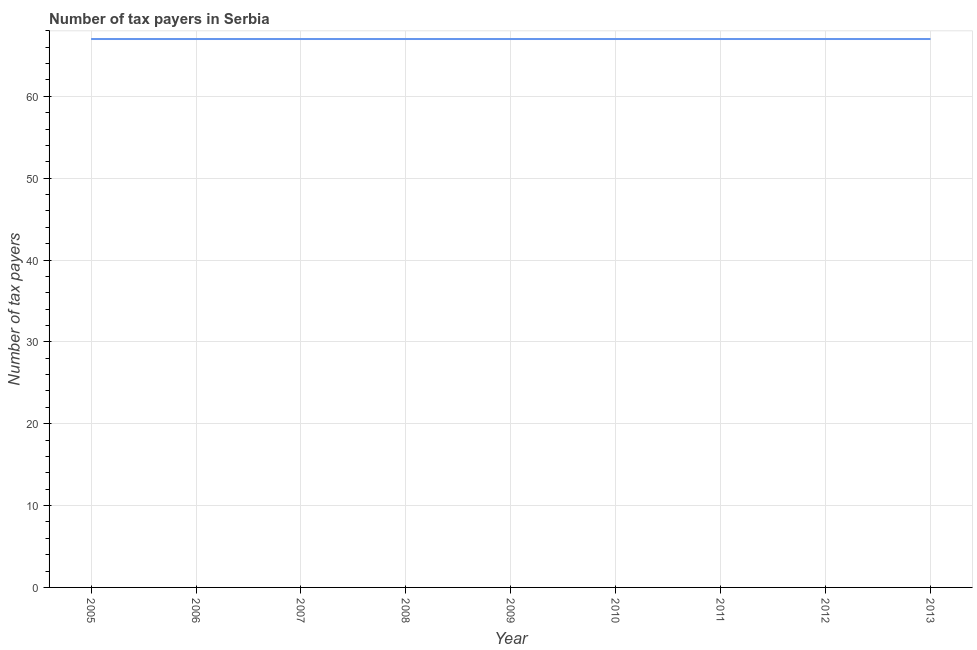What is the number of tax payers in 2011?
Your response must be concise. 67. Across all years, what is the maximum number of tax payers?
Your response must be concise. 67. Across all years, what is the minimum number of tax payers?
Give a very brief answer. 67. In which year was the number of tax payers maximum?
Keep it short and to the point. 2005. In which year was the number of tax payers minimum?
Provide a short and direct response. 2005. What is the sum of the number of tax payers?
Your answer should be very brief. 603. What is the average number of tax payers per year?
Keep it short and to the point. 67. What is the ratio of the number of tax payers in 2008 to that in 2011?
Give a very brief answer. 1. Is the difference between the number of tax payers in 2011 and 2012 greater than the difference between any two years?
Your response must be concise. Yes. What is the difference between the highest and the lowest number of tax payers?
Give a very brief answer. 0. In how many years, is the number of tax payers greater than the average number of tax payers taken over all years?
Keep it short and to the point. 0. How many lines are there?
Ensure brevity in your answer.  1. How many years are there in the graph?
Ensure brevity in your answer.  9. What is the title of the graph?
Offer a terse response. Number of tax payers in Serbia. What is the label or title of the Y-axis?
Provide a succinct answer. Number of tax payers. What is the Number of tax payers in 2005?
Your answer should be compact. 67. What is the Number of tax payers in 2010?
Your answer should be compact. 67. What is the Number of tax payers in 2013?
Make the answer very short. 67. What is the difference between the Number of tax payers in 2005 and 2009?
Your answer should be compact. 0. What is the difference between the Number of tax payers in 2005 and 2010?
Make the answer very short. 0. What is the difference between the Number of tax payers in 2005 and 2011?
Give a very brief answer. 0. What is the difference between the Number of tax payers in 2005 and 2012?
Offer a terse response. 0. What is the difference between the Number of tax payers in 2006 and 2007?
Provide a short and direct response. 0. What is the difference between the Number of tax payers in 2006 and 2008?
Ensure brevity in your answer.  0. What is the difference between the Number of tax payers in 2006 and 2009?
Your answer should be very brief. 0. What is the difference between the Number of tax payers in 2006 and 2012?
Offer a very short reply. 0. What is the difference between the Number of tax payers in 2007 and 2009?
Provide a succinct answer. 0. What is the difference between the Number of tax payers in 2007 and 2010?
Offer a terse response. 0. What is the difference between the Number of tax payers in 2007 and 2011?
Offer a terse response. 0. What is the difference between the Number of tax payers in 2007 and 2012?
Offer a very short reply. 0. What is the difference between the Number of tax payers in 2008 and 2009?
Keep it short and to the point. 0. What is the difference between the Number of tax payers in 2009 and 2012?
Ensure brevity in your answer.  0. What is the difference between the Number of tax payers in 2010 and 2013?
Give a very brief answer. 0. What is the difference between the Number of tax payers in 2012 and 2013?
Provide a succinct answer. 0. What is the ratio of the Number of tax payers in 2005 to that in 2008?
Offer a terse response. 1. What is the ratio of the Number of tax payers in 2005 to that in 2010?
Your answer should be very brief. 1. What is the ratio of the Number of tax payers in 2005 to that in 2012?
Make the answer very short. 1. What is the ratio of the Number of tax payers in 2005 to that in 2013?
Provide a short and direct response. 1. What is the ratio of the Number of tax payers in 2006 to that in 2010?
Make the answer very short. 1. What is the ratio of the Number of tax payers in 2006 to that in 2011?
Provide a short and direct response. 1. What is the ratio of the Number of tax payers in 2006 to that in 2012?
Ensure brevity in your answer.  1. What is the ratio of the Number of tax payers in 2007 to that in 2010?
Ensure brevity in your answer.  1. What is the ratio of the Number of tax payers in 2007 to that in 2011?
Offer a very short reply. 1. What is the ratio of the Number of tax payers in 2007 to that in 2012?
Your response must be concise. 1. What is the ratio of the Number of tax payers in 2007 to that in 2013?
Your response must be concise. 1. What is the ratio of the Number of tax payers in 2008 to that in 2009?
Offer a terse response. 1. What is the ratio of the Number of tax payers in 2008 to that in 2010?
Provide a short and direct response. 1. What is the ratio of the Number of tax payers in 2008 to that in 2011?
Keep it short and to the point. 1. What is the ratio of the Number of tax payers in 2008 to that in 2013?
Your answer should be compact. 1. What is the ratio of the Number of tax payers in 2009 to that in 2010?
Make the answer very short. 1. What is the ratio of the Number of tax payers in 2009 to that in 2011?
Keep it short and to the point. 1. What is the ratio of the Number of tax payers in 2010 to that in 2011?
Your response must be concise. 1. What is the ratio of the Number of tax payers in 2010 to that in 2012?
Ensure brevity in your answer.  1. What is the ratio of the Number of tax payers in 2010 to that in 2013?
Give a very brief answer. 1. What is the ratio of the Number of tax payers in 2011 to that in 2012?
Your response must be concise. 1. 